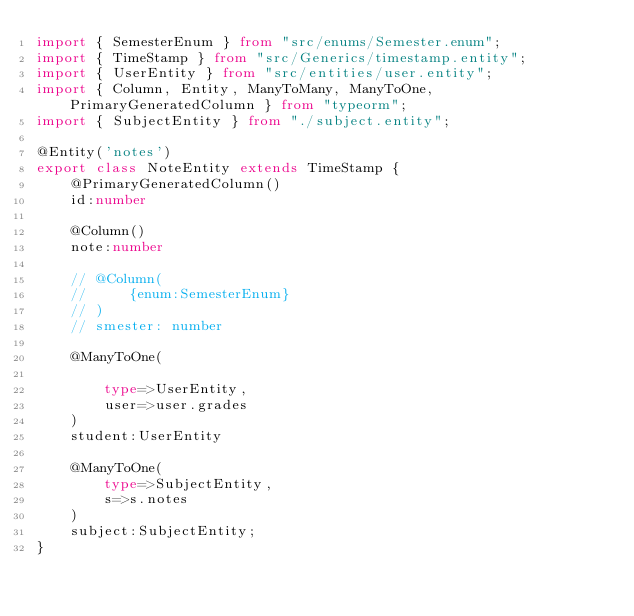Convert code to text. <code><loc_0><loc_0><loc_500><loc_500><_TypeScript_>import { SemesterEnum } from "src/enums/Semester.enum";
import { TimeStamp } from "src/Generics/timestamp.entity";
import { UserEntity } from "src/entities/user.entity";
import { Column, Entity, ManyToMany, ManyToOne, PrimaryGeneratedColumn } from "typeorm";
import { SubjectEntity } from "./subject.entity";

@Entity('notes')
export class NoteEntity extends TimeStamp {
    @PrimaryGeneratedColumn()
    id:number

    @Column()
    note:number

    // @Column(
    //     {enum:SemesterEnum}
    // )
    // smester: number

    @ManyToOne(

        type=>UserEntity,
        user=>user.grades
    )
    student:UserEntity

    @ManyToOne(
        type=>SubjectEntity,
        s=>s.notes
    )
    subject:SubjectEntity;
}
</code> 